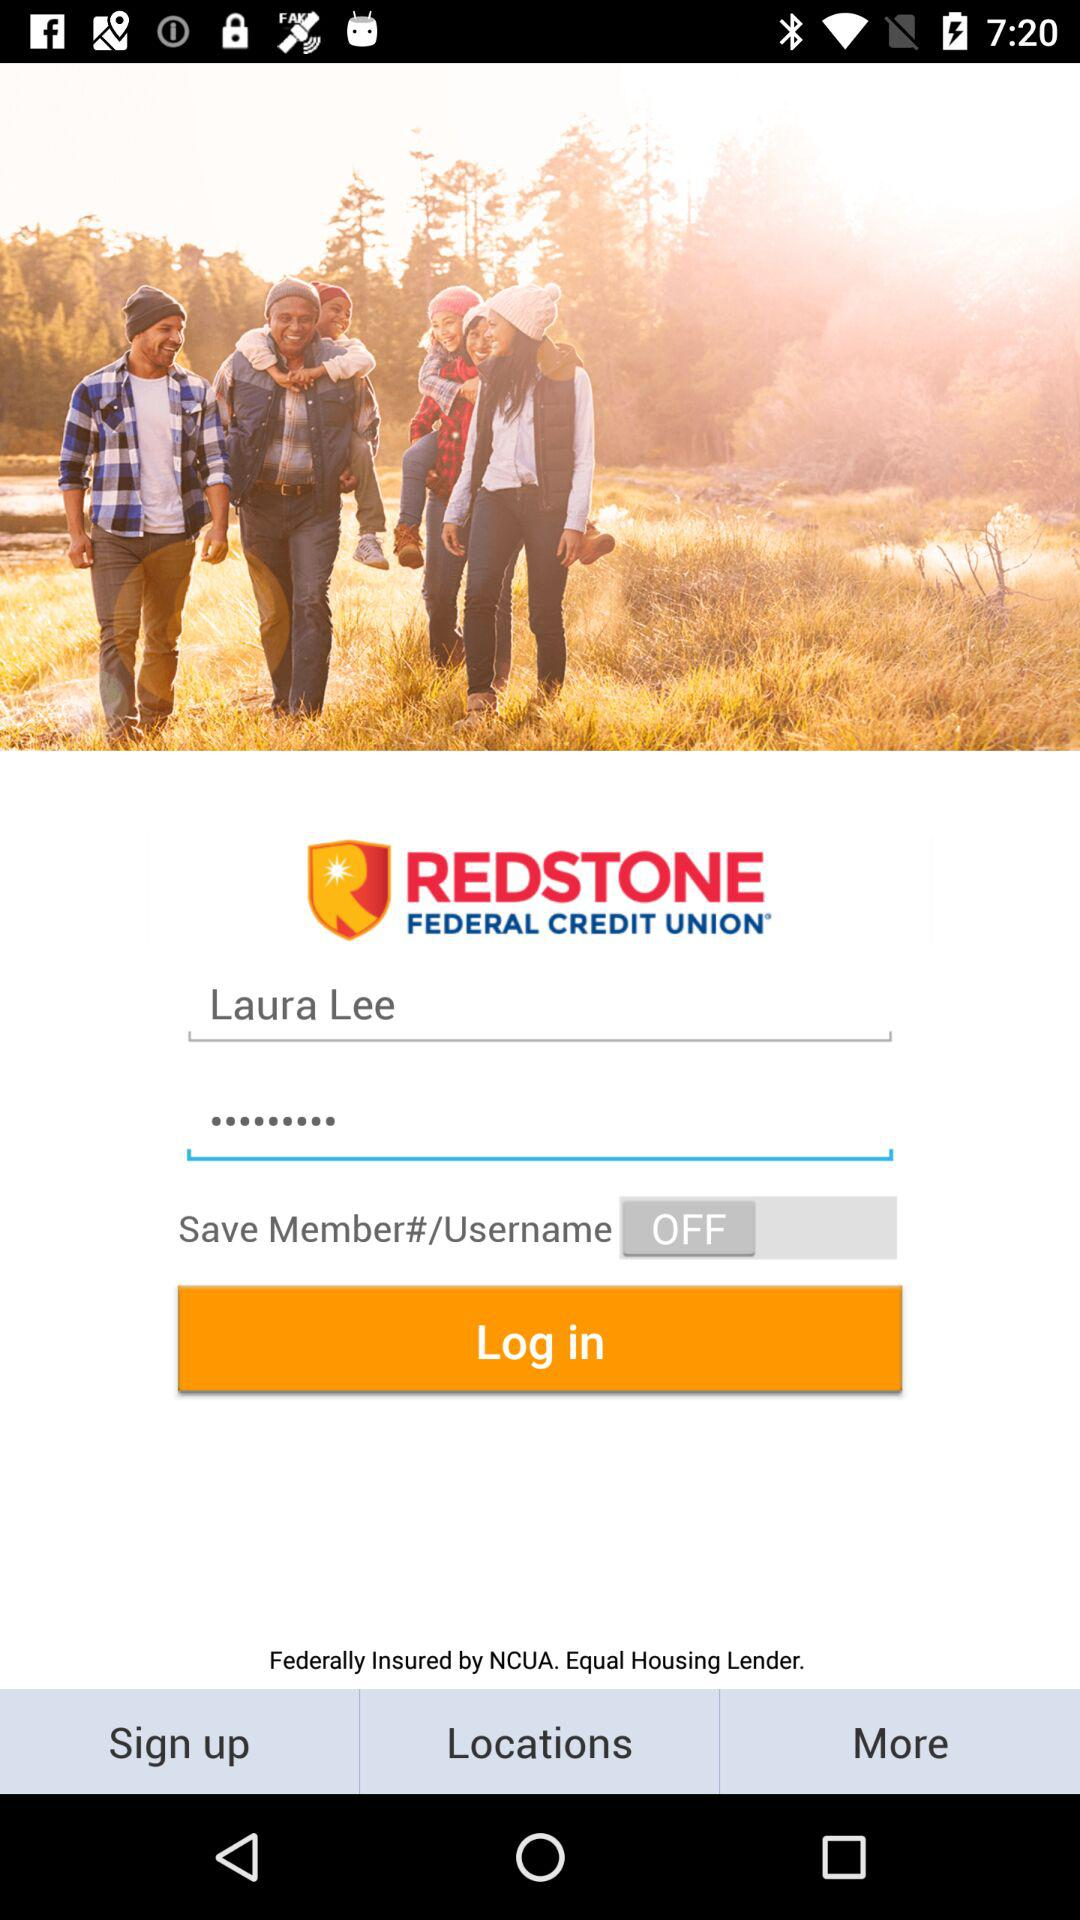What is the app title? The app title is "REDSTONE FEDERAL CREDIT UNION". 